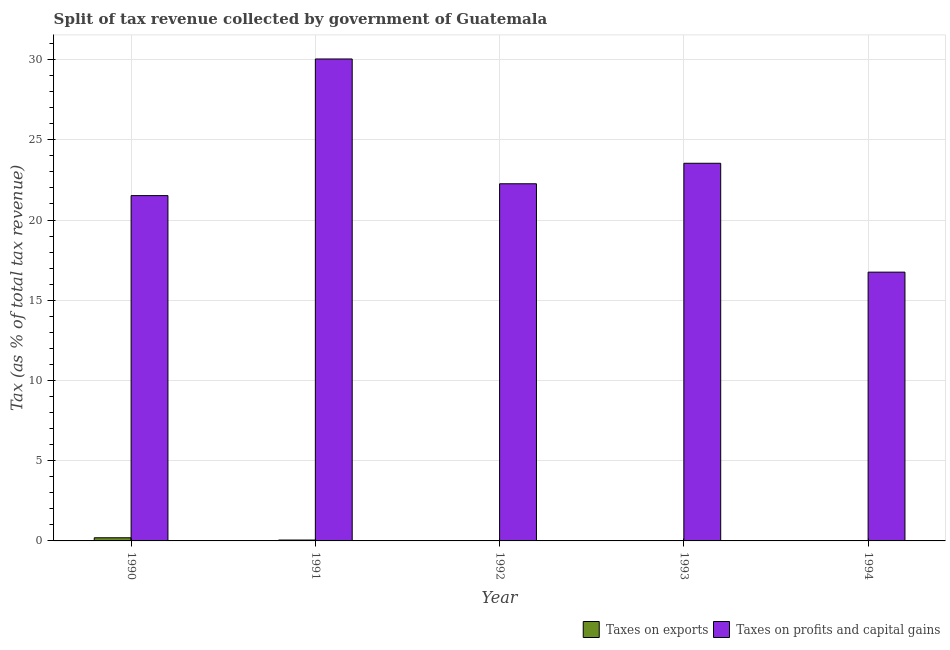How many different coloured bars are there?
Provide a short and direct response. 2. Are the number of bars per tick equal to the number of legend labels?
Keep it short and to the point. Yes. Are the number of bars on each tick of the X-axis equal?
Keep it short and to the point. Yes. How many bars are there on the 4th tick from the right?
Your response must be concise. 2. What is the label of the 3rd group of bars from the left?
Your answer should be compact. 1992. In how many cases, is the number of bars for a given year not equal to the number of legend labels?
Your response must be concise. 0. What is the percentage of revenue obtained from taxes on profits and capital gains in 1992?
Provide a succinct answer. 22.26. Across all years, what is the maximum percentage of revenue obtained from taxes on exports?
Keep it short and to the point. 0.2. Across all years, what is the minimum percentage of revenue obtained from taxes on profits and capital gains?
Give a very brief answer. 16.75. In which year was the percentage of revenue obtained from taxes on profits and capital gains minimum?
Ensure brevity in your answer.  1994. What is the total percentage of revenue obtained from taxes on profits and capital gains in the graph?
Offer a very short reply. 114.1. What is the difference between the percentage of revenue obtained from taxes on exports in 1990 and that in 1992?
Keep it short and to the point. 0.18. What is the difference between the percentage of revenue obtained from taxes on profits and capital gains in 1994 and the percentage of revenue obtained from taxes on exports in 1992?
Keep it short and to the point. -5.51. What is the average percentage of revenue obtained from taxes on profits and capital gains per year?
Give a very brief answer. 22.82. What is the ratio of the percentage of revenue obtained from taxes on profits and capital gains in 1992 to that in 1993?
Offer a very short reply. 0.95. What is the difference between the highest and the second highest percentage of revenue obtained from taxes on exports?
Provide a succinct answer. 0.14. What is the difference between the highest and the lowest percentage of revenue obtained from taxes on profits and capital gains?
Give a very brief answer. 13.29. What does the 2nd bar from the left in 1993 represents?
Give a very brief answer. Taxes on profits and capital gains. What does the 2nd bar from the right in 1992 represents?
Keep it short and to the point. Taxes on exports. How many bars are there?
Your answer should be very brief. 10. Are all the bars in the graph horizontal?
Your answer should be very brief. No. How many years are there in the graph?
Make the answer very short. 5. Are the values on the major ticks of Y-axis written in scientific E-notation?
Your answer should be very brief. No. How many legend labels are there?
Your answer should be compact. 2. How are the legend labels stacked?
Offer a terse response. Horizontal. What is the title of the graph?
Make the answer very short. Split of tax revenue collected by government of Guatemala. What is the label or title of the Y-axis?
Keep it short and to the point. Tax (as % of total tax revenue). What is the Tax (as % of total tax revenue) of Taxes on exports in 1990?
Offer a very short reply. 0.2. What is the Tax (as % of total tax revenue) of Taxes on profits and capital gains in 1990?
Provide a succinct answer. 21.52. What is the Tax (as % of total tax revenue) of Taxes on exports in 1991?
Ensure brevity in your answer.  0.06. What is the Tax (as % of total tax revenue) of Taxes on profits and capital gains in 1991?
Make the answer very short. 30.04. What is the Tax (as % of total tax revenue) of Taxes on exports in 1992?
Give a very brief answer. 0.02. What is the Tax (as % of total tax revenue) in Taxes on profits and capital gains in 1992?
Provide a short and direct response. 22.26. What is the Tax (as % of total tax revenue) in Taxes on exports in 1993?
Your answer should be compact. 0. What is the Tax (as % of total tax revenue) in Taxes on profits and capital gains in 1993?
Your answer should be compact. 23.54. What is the Tax (as % of total tax revenue) of Taxes on exports in 1994?
Your answer should be very brief. 0. What is the Tax (as % of total tax revenue) of Taxes on profits and capital gains in 1994?
Your answer should be compact. 16.75. Across all years, what is the maximum Tax (as % of total tax revenue) in Taxes on exports?
Offer a terse response. 0.2. Across all years, what is the maximum Tax (as % of total tax revenue) in Taxes on profits and capital gains?
Make the answer very short. 30.04. Across all years, what is the minimum Tax (as % of total tax revenue) of Taxes on exports?
Your response must be concise. 0. Across all years, what is the minimum Tax (as % of total tax revenue) in Taxes on profits and capital gains?
Make the answer very short. 16.75. What is the total Tax (as % of total tax revenue) in Taxes on exports in the graph?
Offer a terse response. 0.27. What is the total Tax (as % of total tax revenue) of Taxes on profits and capital gains in the graph?
Your answer should be compact. 114.1. What is the difference between the Tax (as % of total tax revenue) in Taxes on exports in 1990 and that in 1991?
Offer a very short reply. 0.14. What is the difference between the Tax (as % of total tax revenue) of Taxes on profits and capital gains in 1990 and that in 1991?
Give a very brief answer. -8.52. What is the difference between the Tax (as % of total tax revenue) of Taxes on exports in 1990 and that in 1992?
Offer a very short reply. 0.18. What is the difference between the Tax (as % of total tax revenue) in Taxes on profits and capital gains in 1990 and that in 1992?
Offer a terse response. -0.74. What is the difference between the Tax (as % of total tax revenue) in Taxes on exports in 1990 and that in 1993?
Ensure brevity in your answer.  0.2. What is the difference between the Tax (as % of total tax revenue) in Taxes on profits and capital gains in 1990 and that in 1993?
Offer a very short reply. -2.02. What is the difference between the Tax (as % of total tax revenue) of Taxes on exports in 1990 and that in 1994?
Give a very brief answer. 0.2. What is the difference between the Tax (as % of total tax revenue) in Taxes on profits and capital gains in 1990 and that in 1994?
Ensure brevity in your answer.  4.77. What is the difference between the Tax (as % of total tax revenue) of Taxes on exports in 1991 and that in 1992?
Keep it short and to the point. 0.04. What is the difference between the Tax (as % of total tax revenue) of Taxes on profits and capital gains in 1991 and that in 1992?
Keep it short and to the point. 7.78. What is the difference between the Tax (as % of total tax revenue) in Taxes on exports in 1991 and that in 1993?
Offer a terse response. 0.06. What is the difference between the Tax (as % of total tax revenue) of Taxes on profits and capital gains in 1991 and that in 1993?
Keep it short and to the point. 6.5. What is the difference between the Tax (as % of total tax revenue) in Taxes on exports in 1991 and that in 1994?
Provide a short and direct response. 0.06. What is the difference between the Tax (as % of total tax revenue) of Taxes on profits and capital gains in 1991 and that in 1994?
Give a very brief answer. 13.29. What is the difference between the Tax (as % of total tax revenue) in Taxes on exports in 1992 and that in 1993?
Make the answer very short. 0.02. What is the difference between the Tax (as % of total tax revenue) in Taxes on profits and capital gains in 1992 and that in 1993?
Make the answer very short. -1.28. What is the difference between the Tax (as % of total tax revenue) of Taxes on exports in 1992 and that in 1994?
Keep it short and to the point. 0.02. What is the difference between the Tax (as % of total tax revenue) of Taxes on profits and capital gains in 1992 and that in 1994?
Give a very brief answer. 5.51. What is the difference between the Tax (as % of total tax revenue) in Taxes on profits and capital gains in 1993 and that in 1994?
Your response must be concise. 6.78. What is the difference between the Tax (as % of total tax revenue) of Taxes on exports in 1990 and the Tax (as % of total tax revenue) of Taxes on profits and capital gains in 1991?
Offer a very short reply. -29.84. What is the difference between the Tax (as % of total tax revenue) of Taxes on exports in 1990 and the Tax (as % of total tax revenue) of Taxes on profits and capital gains in 1992?
Your answer should be very brief. -22.06. What is the difference between the Tax (as % of total tax revenue) of Taxes on exports in 1990 and the Tax (as % of total tax revenue) of Taxes on profits and capital gains in 1993?
Provide a succinct answer. -23.34. What is the difference between the Tax (as % of total tax revenue) of Taxes on exports in 1990 and the Tax (as % of total tax revenue) of Taxes on profits and capital gains in 1994?
Keep it short and to the point. -16.55. What is the difference between the Tax (as % of total tax revenue) of Taxes on exports in 1991 and the Tax (as % of total tax revenue) of Taxes on profits and capital gains in 1992?
Give a very brief answer. -22.2. What is the difference between the Tax (as % of total tax revenue) of Taxes on exports in 1991 and the Tax (as % of total tax revenue) of Taxes on profits and capital gains in 1993?
Your response must be concise. -23.48. What is the difference between the Tax (as % of total tax revenue) in Taxes on exports in 1991 and the Tax (as % of total tax revenue) in Taxes on profits and capital gains in 1994?
Provide a succinct answer. -16.7. What is the difference between the Tax (as % of total tax revenue) in Taxes on exports in 1992 and the Tax (as % of total tax revenue) in Taxes on profits and capital gains in 1993?
Your answer should be compact. -23.52. What is the difference between the Tax (as % of total tax revenue) of Taxes on exports in 1992 and the Tax (as % of total tax revenue) of Taxes on profits and capital gains in 1994?
Keep it short and to the point. -16.73. What is the difference between the Tax (as % of total tax revenue) in Taxes on exports in 1993 and the Tax (as % of total tax revenue) in Taxes on profits and capital gains in 1994?
Offer a very short reply. -16.75. What is the average Tax (as % of total tax revenue) of Taxes on exports per year?
Provide a short and direct response. 0.05. What is the average Tax (as % of total tax revenue) in Taxes on profits and capital gains per year?
Keep it short and to the point. 22.82. In the year 1990, what is the difference between the Tax (as % of total tax revenue) of Taxes on exports and Tax (as % of total tax revenue) of Taxes on profits and capital gains?
Your answer should be compact. -21.32. In the year 1991, what is the difference between the Tax (as % of total tax revenue) in Taxes on exports and Tax (as % of total tax revenue) in Taxes on profits and capital gains?
Offer a terse response. -29.98. In the year 1992, what is the difference between the Tax (as % of total tax revenue) of Taxes on exports and Tax (as % of total tax revenue) of Taxes on profits and capital gains?
Make the answer very short. -22.24. In the year 1993, what is the difference between the Tax (as % of total tax revenue) of Taxes on exports and Tax (as % of total tax revenue) of Taxes on profits and capital gains?
Offer a very short reply. -23.54. In the year 1994, what is the difference between the Tax (as % of total tax revenue) in Taxes on exports and Tax (as % of total tax revenue) in Taxes on profits and capital gains?
Your response must be concise. -16.75. What is the ratio of the Tax (as % of total tax revenue) in Taxes on exports in 1990 to that in 1991?
Your answer should be compact. 3.55. What is the ratio of the Tax (as % of total tax revenue) of Taxes on profits and capital gains in 1990 to that in 1991?
Make the answer very short. 0.72. What is the ratio of the Tax (as % of total tax revenue) in Taxes on exports in 1990 to that in 1992?
Provide a short and direct response. 10.02. What is the ratio of the Tax (as % of total tax revenue) in Taxes on profits and capital gains in 1990 to that in 1992?
Offer a terse response. 0.97. What is the ratio of the Tax (as % of total tax revenue) of Taxes on exports in 1990 to that in 1993?
Your answer should be very brief. 987.29. What is the ratio of the Tax (as % of total tax revenue) of Taxes on profits and capital gains in 1990 to that in 1993?
Keep it short and to the point. 0.91. What is the ratio of the Tax (as % of total tax revenue) in Taxes on exports in 1990 to that in 1994?
Ensure brevity in your answer.  992.76. What is the ratio of the Tax (as % of total tax revenue) of Taxes on profits and capital gains in 1990 to that in 1994?
Offer a very short reply. 1.28. What is the ratio of the Tax (as % of total tax revenue) in Taxes on exports in 1991 to that in 1992?
Provide a succinct answer. 2.83. What is the ratio of the Tax (as % of total tax revenue) of Taxes on profits and capital gains in 1991 to that in 1992?
Give a very brief answer. 1.35. What is the ratio of the Tax (as % of total tax revenue) of Taxes on exports in 1991 to that in 1993?
Provide a succinct answer. 278.35. What is the ratio of the Tax (as % of total tax revenue) in Taxes on profits and capital gains in 1991 to that in 1993?
Your response must be concise. 1.28. What is the ratio of the Tax (as % of total tax revenue) in Taxes on exports in 1991 to that in 1994?
Offer a terse response. 279.89. What is the ratio of the Tax (as % of total tax revenue) of Taxes on profits and capital gains in 1991 to that in 1994?
Your response must be concise. 1.79. What is the ratio of the Tax (as % of total tax revenue) in Taxes on exports in 1992 to that in 1993?
Offer a very short reply. 98.5. What is the ratio of the Tax (as % of total tax revenue) of Taxes on profits and capital gains in 1992 to that in 1993?
Offer a terse response. 0.95. What is the ratio of the Tax (as % of total tax revenue) in Taxes on exports in 1992 to that in 1994?
Ensure brevity in your answer.  99.04. What is the ratio of the Tax (as % of total tax revenue) of Taxes on profits and capital gains in 1992 to that in 1994?
Offer a terse response. 1.33. What is the ratio of the Tax (as % of total tax revenue) of Taxes on exports in 1993 to that in 1994?
Your answer should be compact. 1.01. What is the ratio of the Tax (as % of total tax revenue) of Taxes on profits and capital gains in 1993 to that in 1994?
Give a very brief answer. 1.41. What is the difference between the highest and the second highest Tax (as % of total tax revenue) of Taxes on exports?
Keep it short and to the point. 0.14. What is the difference between the highest and the second highest Tax (as % of total tax revenue) of Taxes on profits and capital gains?
Your response must be concise. 6.5. What is the difference between the highest and the lowest Tax (as % of total tax revenue) of Taxes on exports?
Ensure brevity in your answer.  0.2. What is the difference between the highest and the lowest Tax (as % of total tax revenue) of Taxes on profits and capital gains?
Provide a short and direct response. 13.29. 